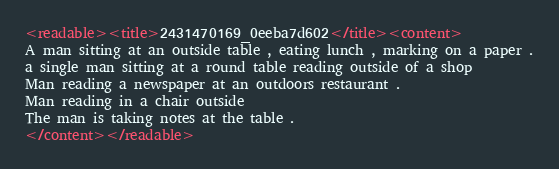Convert code to text. <code><loc_0><loc_0><loc_500><loc_500><_XML_><readable><title>2431470169_0eeba7d602</title><content>
A man sitting at an outside table , eating lunch , marking on a paper .
a single man sitting at a round table reading outside of a shop
Man reading a newspaper at an outdoors restaurant .
Man reading in a chair outside
The man is taking notes at the table .
</content></readable></code> 